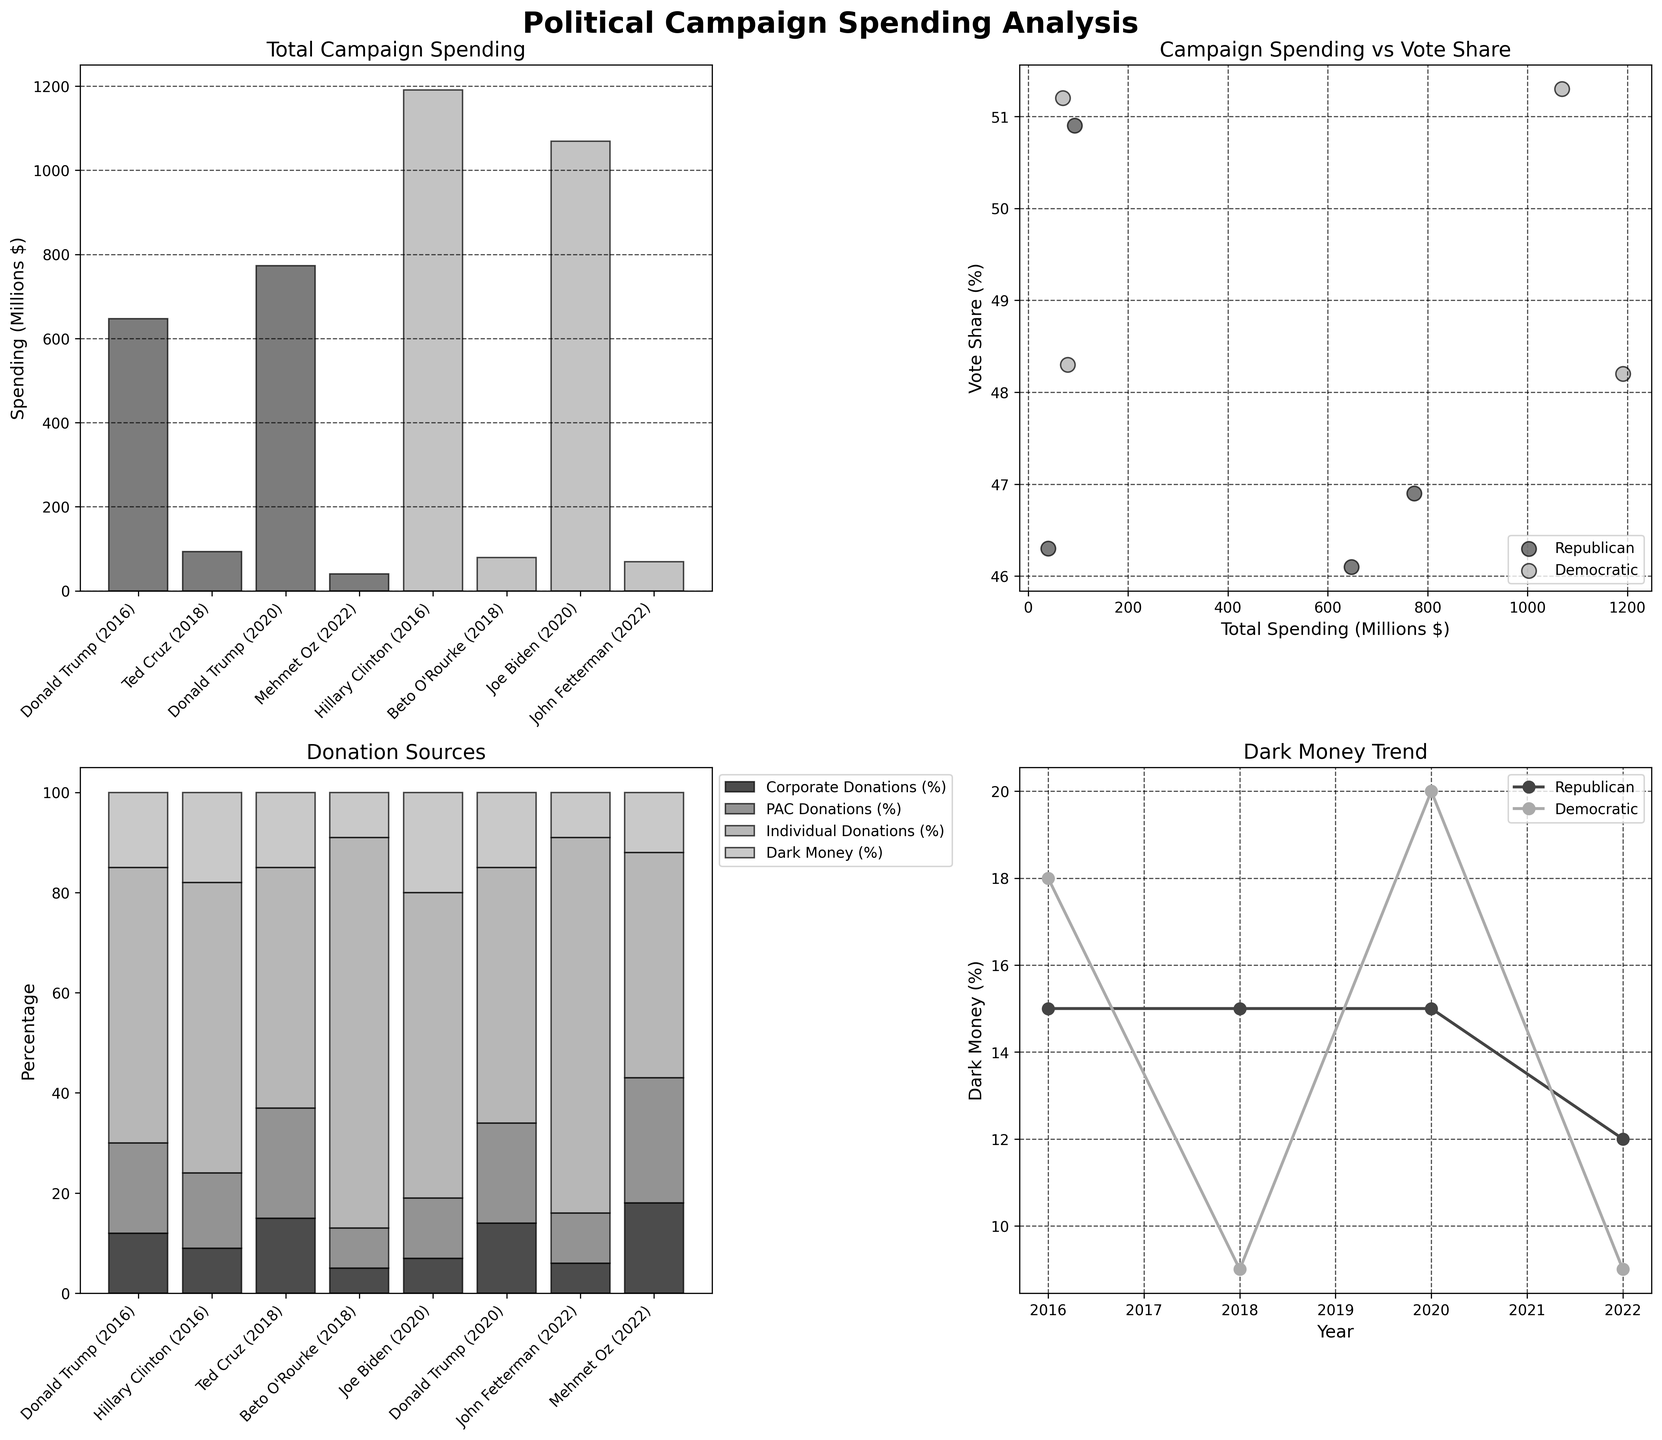Which candidate had the highest total spending? The bar chart in Subplot 1 shows the total spending for each candidate. Hillary Clinton (2016) had the highest bar, indicating the highest total spending.
Answer: Hillary Clinton How does Joe Biden's vote share compare to Donald Trump's in 2020? Refer to Subplot 2 for the scatter plot of vote share vs total spending. Joe Biden (2020) is marked with a higher vote share compared to Donald Trump (2020).
Answer: Joe Biden had a higher vote share What is the general trend of dark money for Democratic candidates across the years? Subplot 4 shows the dark money trend line for each party. For the Democratic candidates, the line clearly trends upwards from 2016 to 2022.
Answer: Upwards Who received the highest percentage of corporate donations in 2022? The stacked bar chart in Subplot 3 shows donation sources by candidate. Compare the corporate donation (first segment of each bar) in Subplot 3 for 2022 candidates. Mehmet Oz received the highest percentage.
Answer: Mehmet Oz Which party's candidates have a higher average vote share across all years? Use Subplot 2 to compare the average vote share of Democratic and Republican candidates by averaging the vote share percentages displayed for each party. The Democratic candidates generally have higher averages.
Answer: Democratic Does spending more money correlate with receiving a higher vote share? Subplot 2, the scatter plot, should be examined for correlation. While there is no strict consistent pattern, a trend line would have a slight positive slope indicating weak positive correlation.
Answer: Weak positive correlation Which candidate had the least individual donations, and how much did they receive? Subplot 3 shows donation percentages. Mehmet Oz’s individual donation segment appears shortest among all candidates.
Answer: Mehmet Oz had the least, 45% How did the percentage of individual donations to Donald Trump change from 2016 to 2020? Compare the individual donations segment of Donald Trump in Subplot 3 for the years 2016 and 2020. It decreased from 55% in 2016 to 51% in 2020.
Answer: Decreased What is the total percentage of PAC donations in 2018 across both parties? Subplot 3 can be used to sum the PAC donations for the candidates in 2018. For Ted Cruz: 22% and for Beto O'Rourke: 8%. Sum them up: 22% + 8% = 30%.
Answer: 30% 